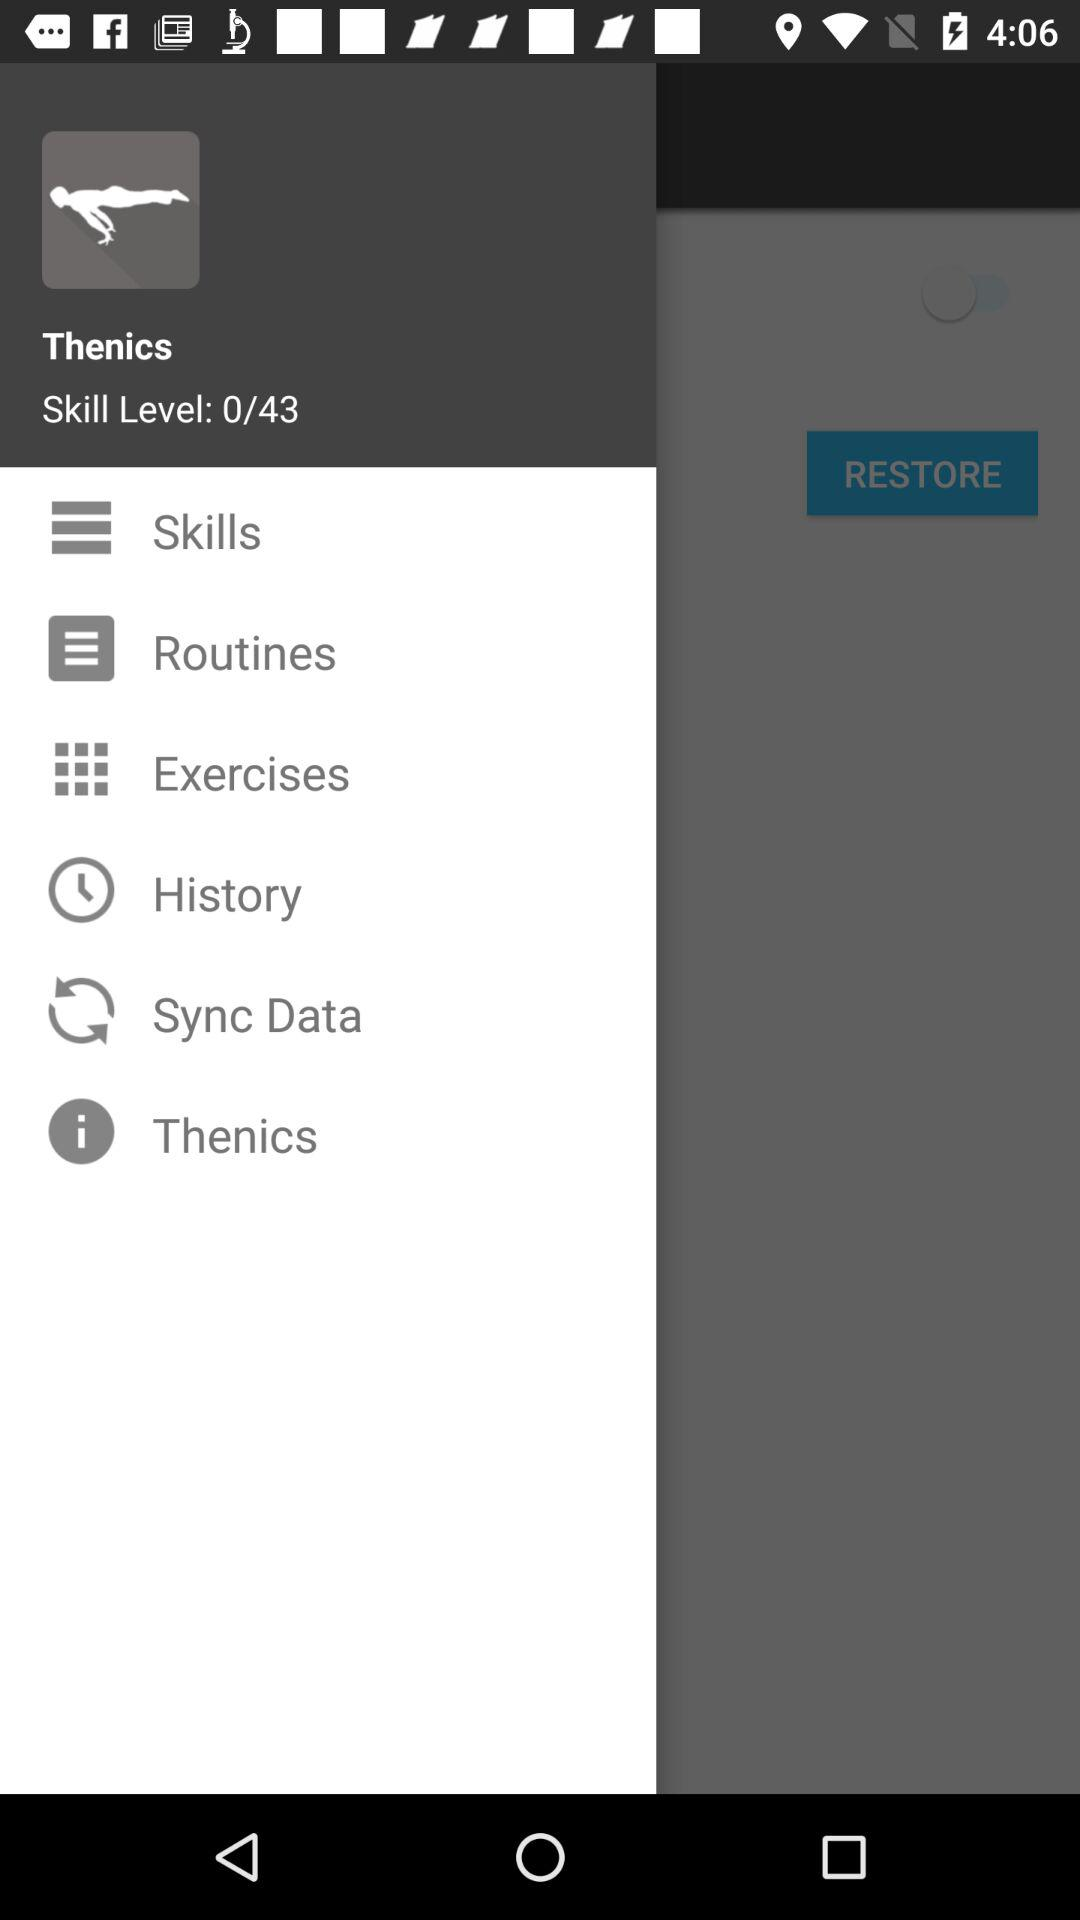How many skill levels are available?
Answer the question using a single word or phrase. 43 